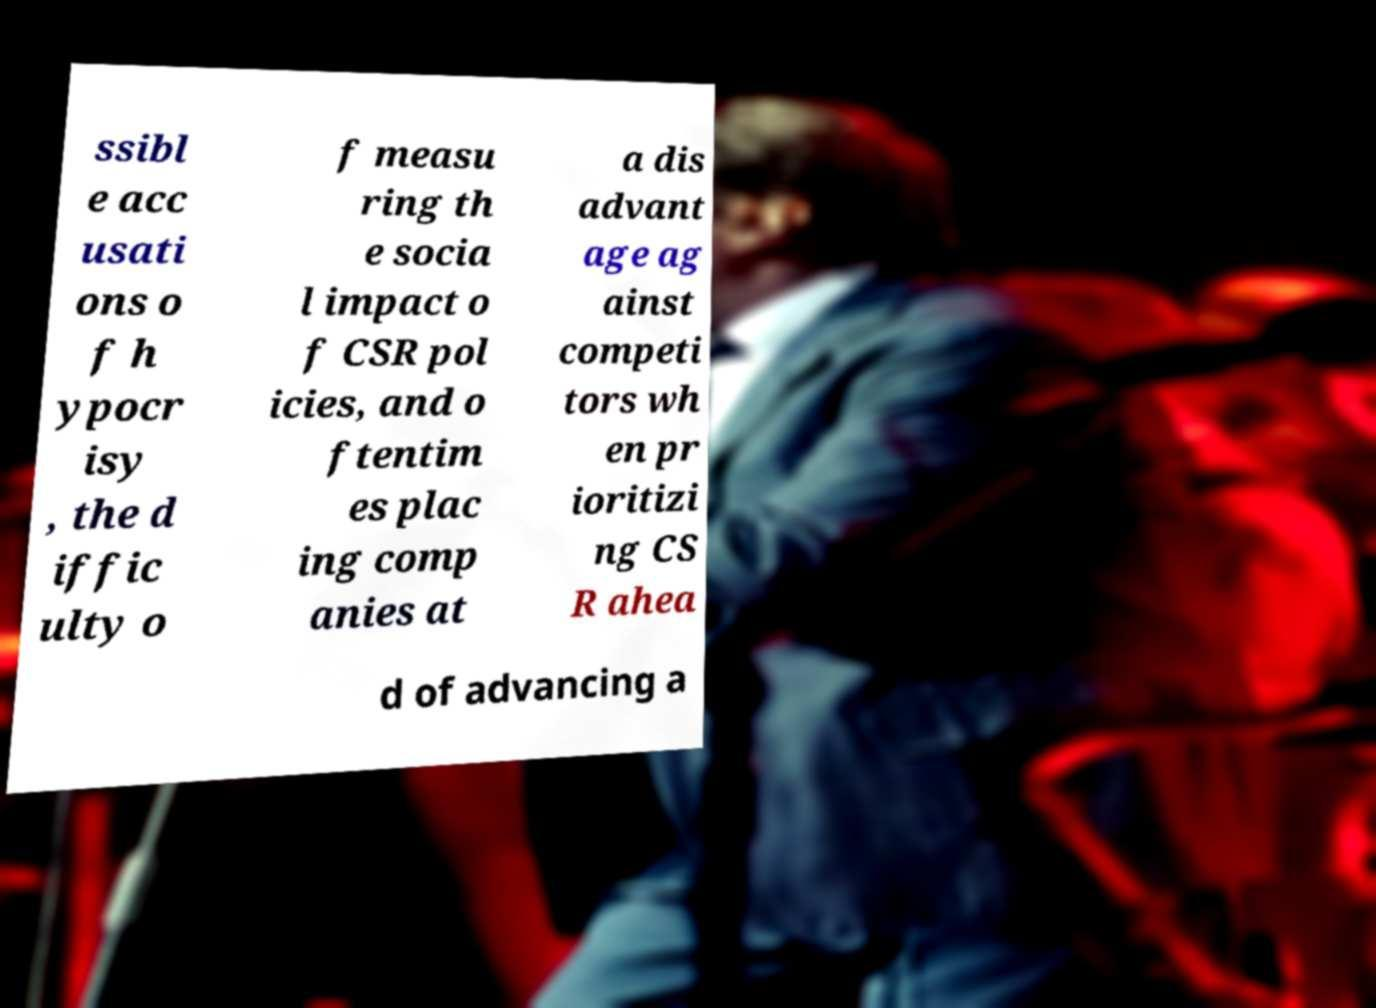Please identify and transcribe the text found in this image. ssibl e acc usati ons o f h ypocr isy , the d iffic ulty o f measu ring th e socia l impact o f CSR pol icies, and o ftentim es plac ing comp anies at a dis advant age ag ainst competi tors wh en pr ioritizi ng CS R ahea d of advancing a 